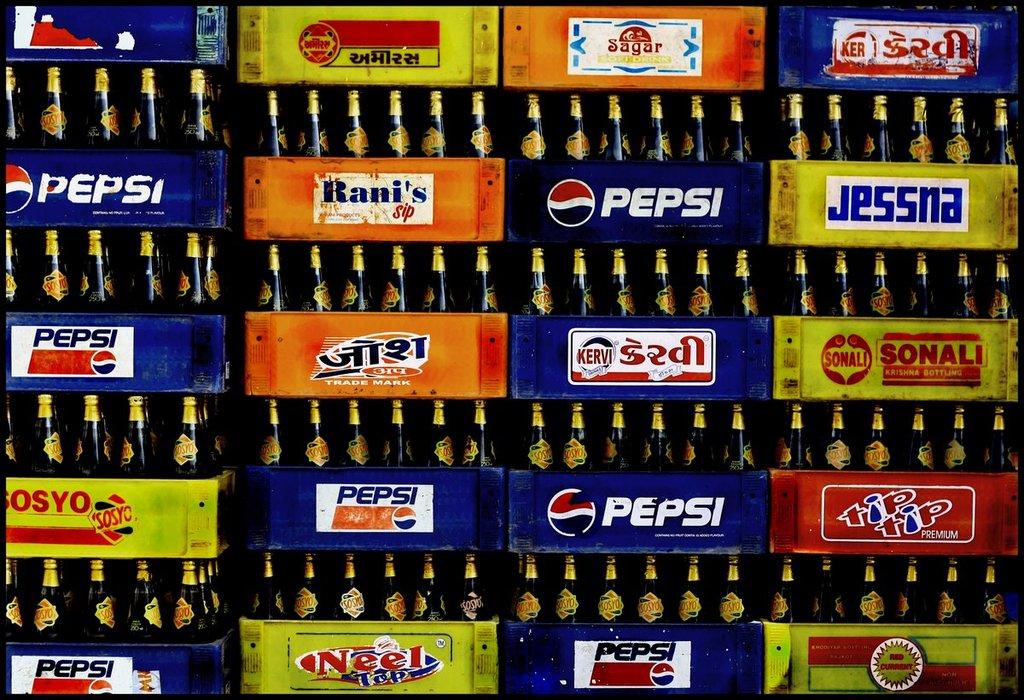Is there a box of tiptip in the stack?
Make the answer very short. Yes. 